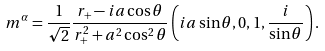<formula> <loc_0><loc_0><loc_500><loc_500>m ^ { \alpha } = \frac { 1 } { \sqrt { 2 } } \frac { r _ { + } - i a \cos \theta } { r _ { + } ^ { 2 } + a ^ { 2 } \cos ^ { 2 } \theta } \left ( i a \sin \theta , 0 , 1 , \frac { i } { \sin \theta } \right ) .</formula> 